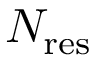Convert formula to latex. <formula><loc_0><loc_0><loc_500><loc_500>N _ { r e s }</formula> 